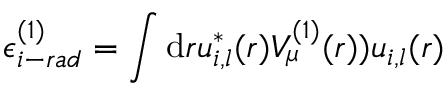Convert formula to latex. <formula><loc_0><loc_0><loc_500><loc_500>\epsilon _ { i - r a d } ^ { ( 1 ) } = \int d { r } u _ { i , l } ^ { * } ( r ) V _ { \mu } ^ { ( 1 ) } ( r ) ) u _ { i , l } ( r )</formula> 